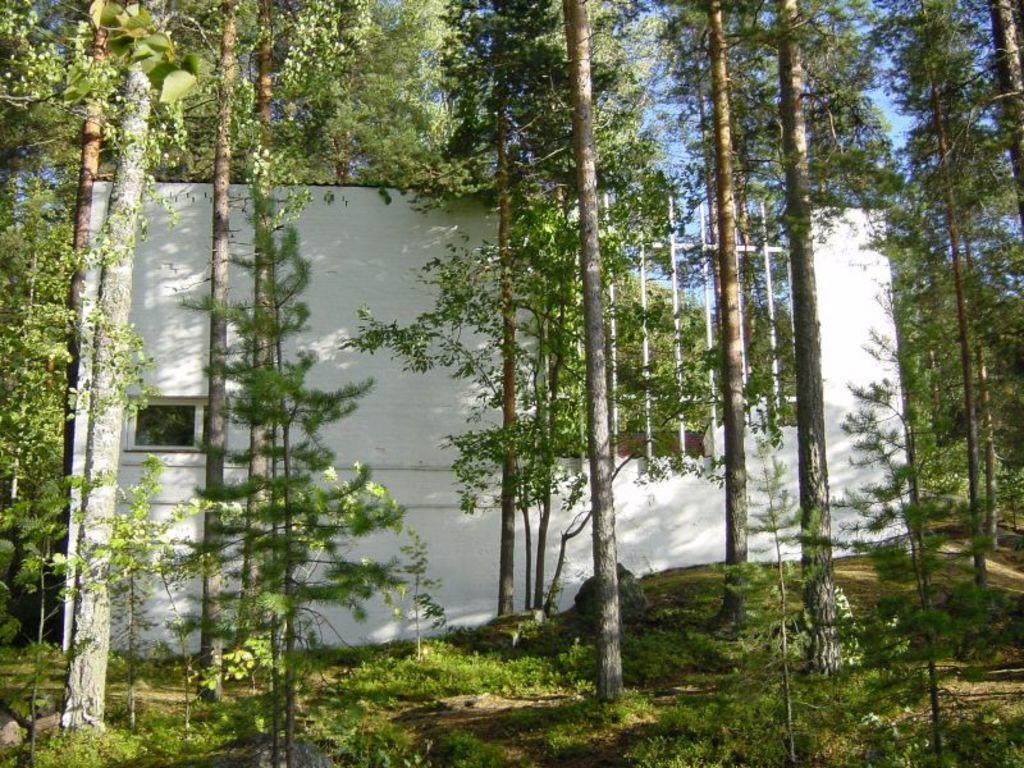In one or two sentences, can you explain what this image depicts? In the center of the image there are trees. In the background there is a building. At the bottom there is grass. 